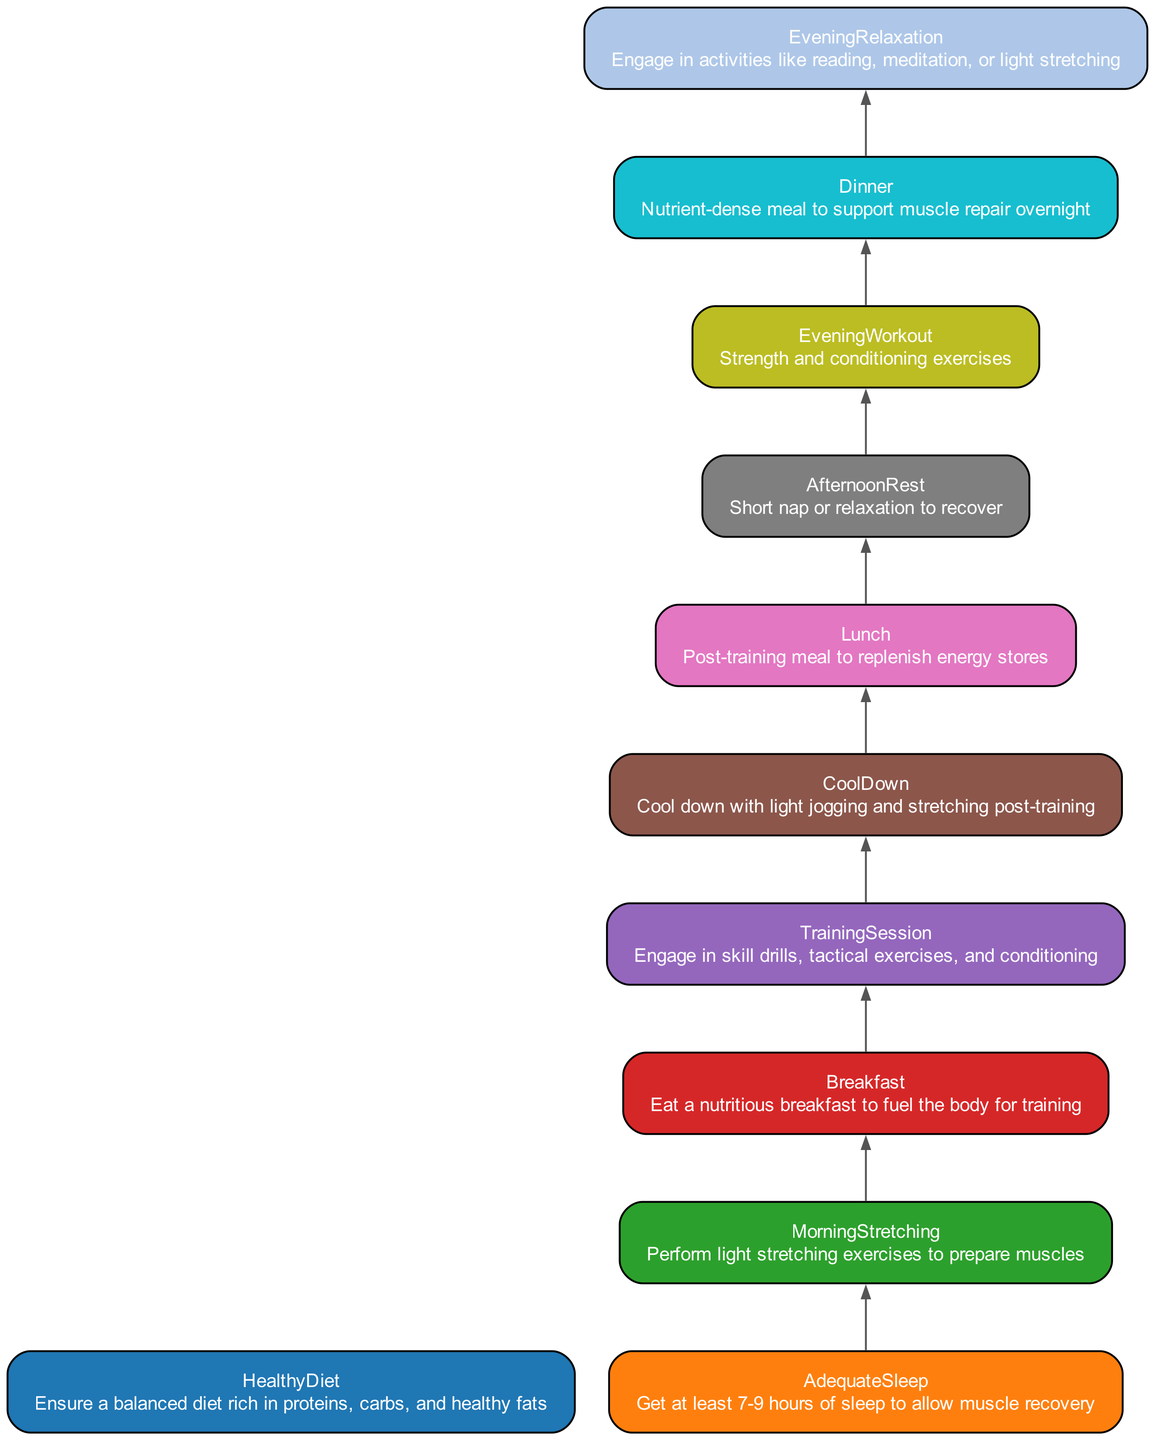What is the first activity in the flowchart? Based on the flow of the diagram from bottom to top, the first activity is "HealthyDiet," as it has no dependencies and is at the base of the flow.
Answer: HealthyDiet How many edges are in the diagram? To find the total number of edges, we can count each dependency relationship from one activity to another. In this case, there are 10 edges that connect the various nodes based on their dependencies.
Answer: 10 What activity directly follows "CoolDown"? The activity "Lunch" directly follows "CoolDown" as indicated by the dependency relationship where "CoolDown" is a prerequisite for "Lunch."
Answer: Lunch What is the last activity in the flowchart? The last activity in the flowchart is "EveningRelaxation," since it has dependencies that come from previous activities and ends the daily time management sequence.
Answer: EveningRelaxation Which activity depends on both "Lunch" and "Dinner"? The diagram shows that no single activity depends specifically on both "Lunch" and "Dinner." Therefore, the answer is there is no such activity.
Answer: None Which activity is the prerequisite for "TrainingSession"? The prerequisite for "TrainingSession" is "Breakfast," which is needed before engaging in training exercises.
Answer: Breakfast How many activities follow "MorningStretching"? The only activity that follows "MorningStretching" in the diagram is "Breakfast," making the count equal to one.
Answer: One What are the three activities that occur after "Dinner"? From the diagram, the activities that occur after "Dinner" is "EveningRelaxation," which is the only activity listed following it.
Answer: EveningRelaxation What is the dependency chain leading to "EveningWorkout"? The dependency chain leading to "EveningWorkout" starts from "Lunch," which leads to "AfternoonRest," and then finally to "EveningWorkout." Therefore, the chain is "Lunch → AfternoonRest → EveningWorkout."
Answer: Lunch → AfternoonRest → EveningWorkout 